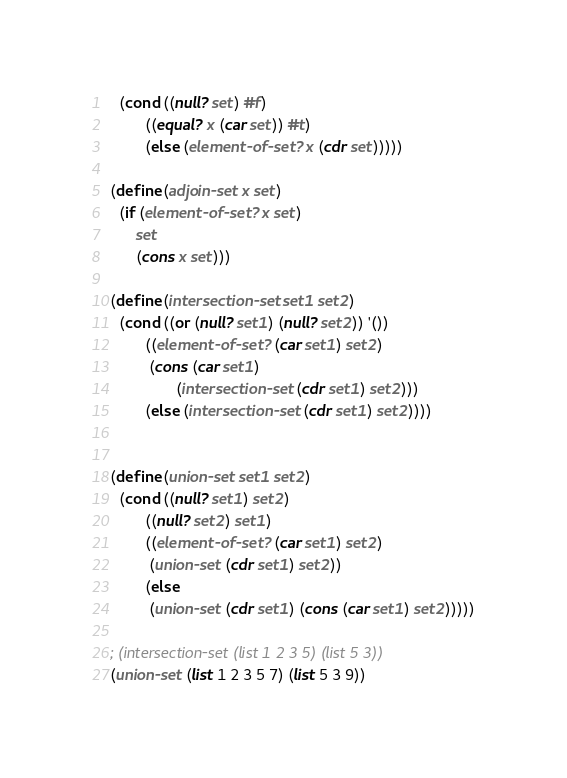Convert code to text. <code><loc_0><loc_0><loc_500><loc_500><_Scheme_>  (cond ((null? set) #f)
        ((equal? x (car set)) #t)
        (else (element-of-set? x (cdr set)))))

(define (adjoin-set x set)
  (if (element-of-set? x set)
      set
      (cons x set)))

(define (intersection-set set1 set2)
  (cond ((or (null? set1) (null? set2)) '())
        ((element-of-set? (car set1) set2)
         (cons (car set1)
               (intersection-set (cdr set1) set2)))
        (else (intersection-set (cdr set1) set2))))


(define (union-set set1 set2)
  (cond ((null? set1) set2)
        ((null? set2) set1)
        ((element-of-set? (car set1) set2)
         (union-set (cdr set1) set2))
        (else 
         (union-set (cdr set1) (cons (car set1) set2)))))

; (intersection-set (list 1 2 3 5) (list 5 3))
(union-set (list 1 2 3 5 7) (list 5 3 9))


</code> 